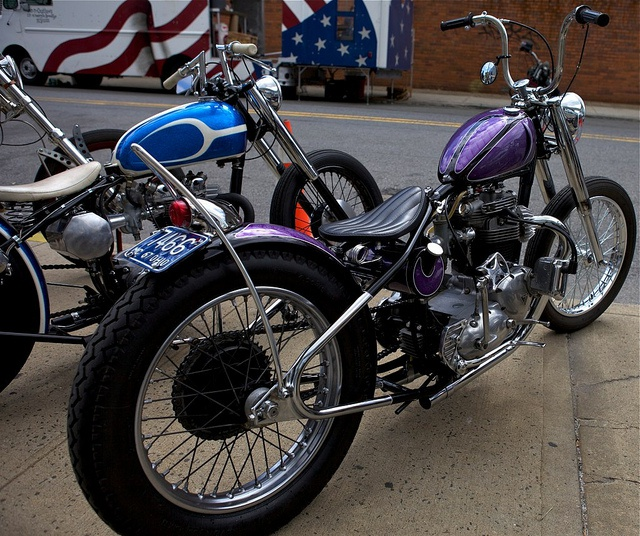Describe the objects in this image and their specific colors. I can see motorcycle in black, gray, darkgray, and lavender tones, motorcycle in black, gray, darkgray, and navy tones, truck in black, gray, and maroon tones, and bus in black and gray tones in this image. 